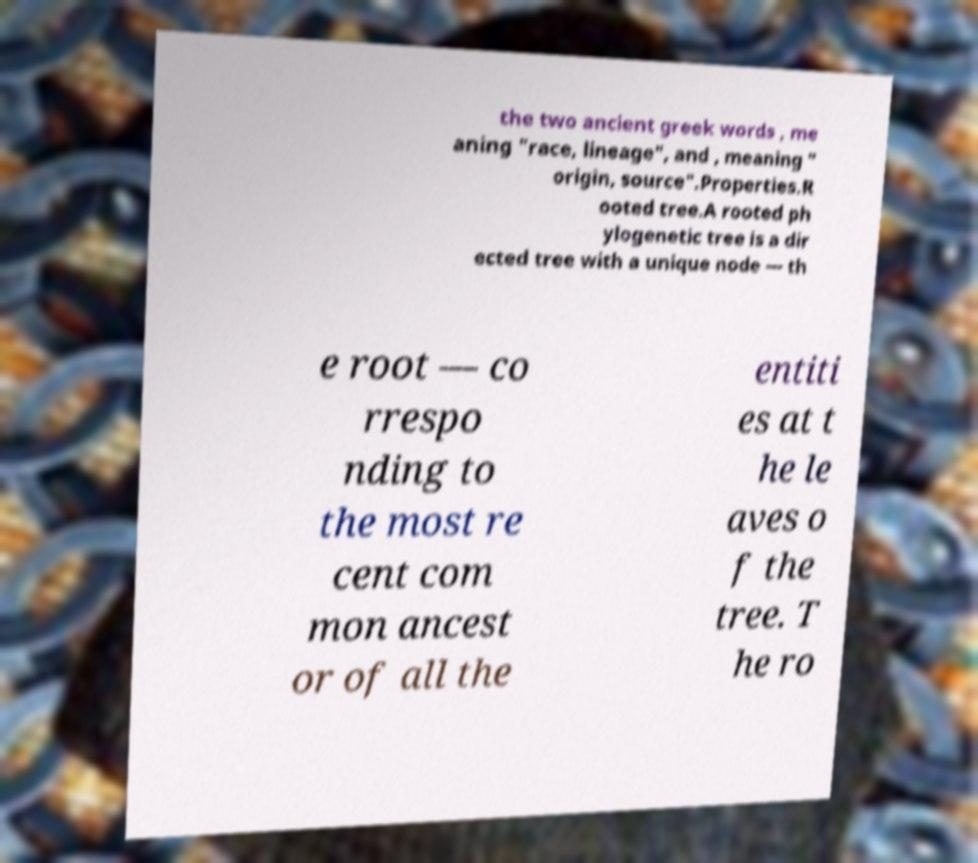There's text embedded in this image that I need extracted. Can you transcribe it verbatim? the two ancient greek words , me aning "race, lineage", and , meaning " origin, source".Properties.R ooted tree.A rooted ph ylogenetic tree is a dir ected tree with a unique node — th e root — co rrespo nding to the most re cent com mon ancest or of all the entiti es at t he le aves o f the tree. T he ro 